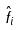Convert formula to latex. <formula><loc_0><loc_0><loc_500><loc_500>\hat { f } _ { i }</formula> 